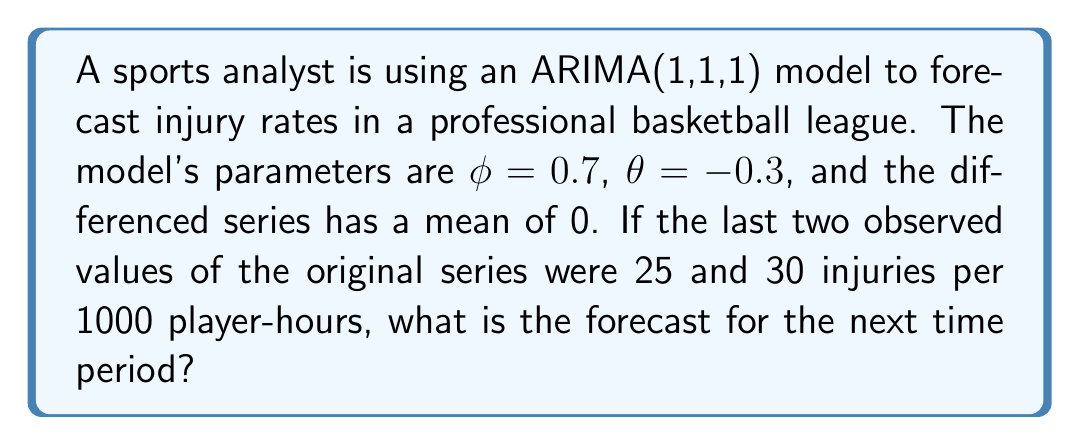Could you help me with this problem? Let's approach this step-by-step:

1) The ARIMA(1,1,1) model can be written as:
   $$(1-\phi B)(1-B)Y_t = (1+\theta B)\epsilon_t$$

2) For forecasting, we use the difference equation form:
   $$Y_t - Y_{t-1} = \phi(Y_{t-1} - Y_{t-2}) + \epsilon_t + \theta\epsilon_{t-1}$$

3) Let's denote the forecast for time $t+1$ as $\hat{Y}_{t+1}$. We need to calculate:
   $$\hat{Y}_{t+1} - Y_t = \phi(Y_t - Y_{t-1}) + \theta\epsilon_t$$

4) We know $Y_t = 30$ and $Y_{t-1} = 25$. We need to estimate $\epsilon_t$.

5) $\epsilon_t$ can be estimated as the difference between the observed value and the one-step-ahead forecast:
   $$\epsilon_t \approx Y_t - \hat{Y}_t = Y_t - (Y_{t-1} + \phi(Y_{t-1} - Y_{t-2}) + \theta\epsilon_{t-1})$$

6) We don't know $Y_{t-2}$ or $\epsilon_{t-1}$, but we can approximate by assuming they're close to their expected values:
   $$\epsilon_t \approx 30 - (25 + 0.7(25 - 25) + 0) = 5$$

7) Now we can forecast:
   $$\hat{Y}_{t+1} - 30 = 0.7(30 - 25) + (-0.3)(5)$$
   $$\hat{Y}_{t+1} - 30 = 3.5 - 1.5 = 2$$

8) Therefore:
   $$\hat{Y}_{t+1} = 30 + 2 = 32$$
Answer: 32 injuries per 1000 player-hours 